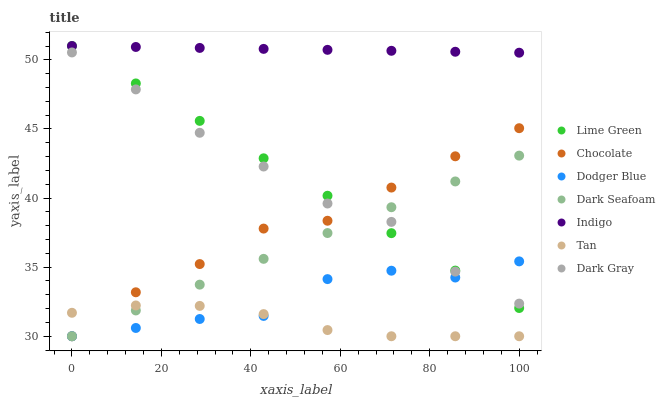Does Tan have the minimum area under the curve?
Answer yes or no. Yes. Does Indigo have the maximum area under the curve?
Answer yes or no. Yes. Does Chocolate have the minimum area under the curve?
Answer yes or no. No. Does Chocolate have the maximum area under the curve?
Answer yes or no. No. Is Indigo the smoothest?
Answer yes or no. Yes. Is Dodger Blue the roughest?
Answer yes or no. Yes. Is Chocolate the smoothest?
Answer yes or no. No. Is Chocolate the roughest?
Answer yes or no. No. Does Chocolate have the lowest value?
Answer yes or no. Yes. Does Dark Gray have the lowest value?
Answer yes or no. No. Does Lime Green have the highest value?
Answer yes or no. Yes. Does Chocolate have the highest value?
Answer yes or no. No. Is Dodger Blue less than Indigo?
Answer yes or no. Yes. Is Indigo greater than Dark Gray?
Answer yes or no. Yes. Does Dodger Blue intersect Dark Gray?
Answer yes or no. Yes. Is Dodger Blue less than Dark Gray?
Answer yes or no. No. Is Dodger Blue greater than Dark Gray?
Answer yes or no. No. Does Dodger Blue intersect Indigo?
Answer yes or no. No. 